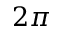Convert formula to latex. <formula><loc_0><loc_0><loc_500><loc_500>2 \pi</formula> 